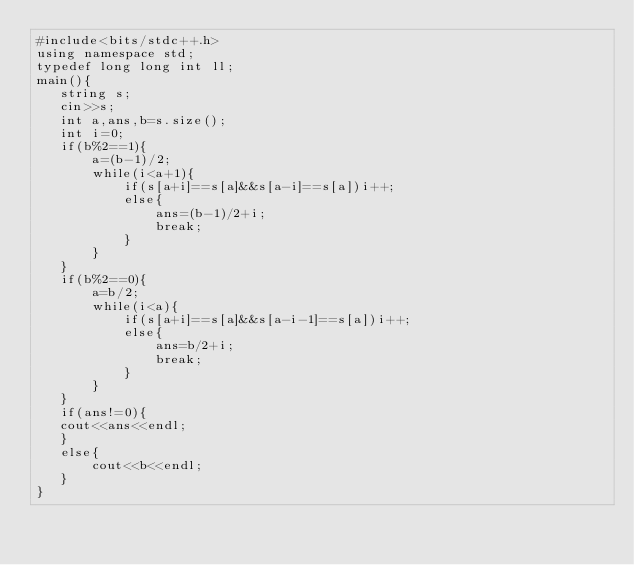<code> <loc_0><loc_0><loc_500><loc_500><_C++_>#include<bits/stdc++.h>
using namespace std;
typedef long long int ll;
main(){
   string s;
   cin>>s;
   int a,ans,b=s.size();
   int i=0;
   if(b%2==1){
       a=(b-1)/2;
       while(i<a+1){
           if(s[a+i]==s[a]&&s[a-i]==s[a])i++;
           else{
               ans=(b-1)/2+i;
               break;
           }
       }
   }
   if(b%2==0){
       a=b/2;
       while(i<a){
           if(s[a+i]==s[a]&&s[a-i-1]==s[a])i++;
           else{
               ans=b/2+i;
               break;
           }
       }
   }
   if(ans!=0){
   cout<<ans<<endl;
   }
   else{
       cout<<b<<endl;
   }
}</code> 